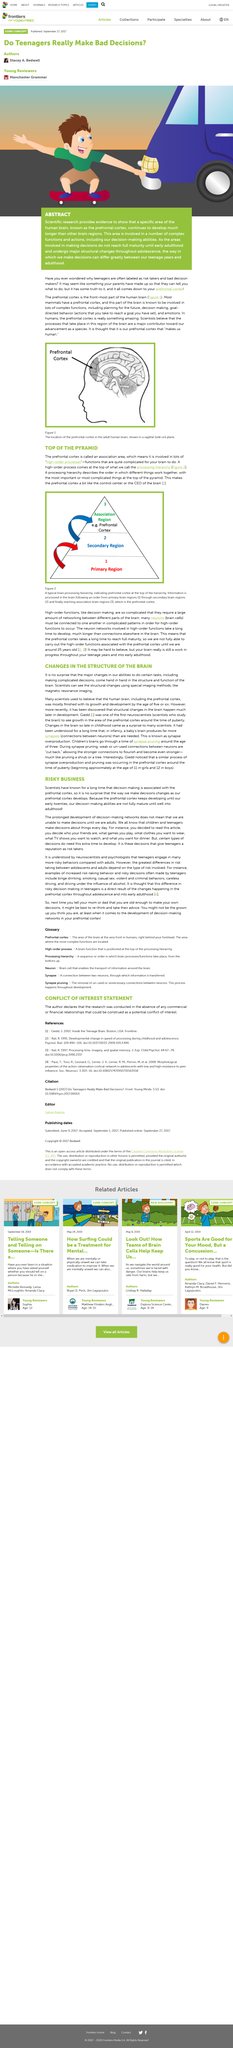Indicate a few pertinent items in this graphic. The reputation that some teenagers have as being risky decision-makers is due to the fact that these decisions require additional time for development. The label that teenagers are often risk takers has some degree of truth to it. Mammals, including most mammals, have a prefrontal cortex. It is at the age of 25 that a human's prefrontal cortex is considered to be fully mature. The decision-making process is associated with the prefrontal cortex. 